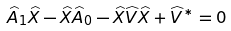Convert formula to latex. <formula><loc_0><loc_0><loc_500><loc_500>\widehat { A } _ { 1 } \widehat { X } - \widehat { X } \widehat { A } _ { 0 } - \widehat { X } \widehat { V } \widehat { X } + \widehat { V } ^ { \ast } = 0</formula> 